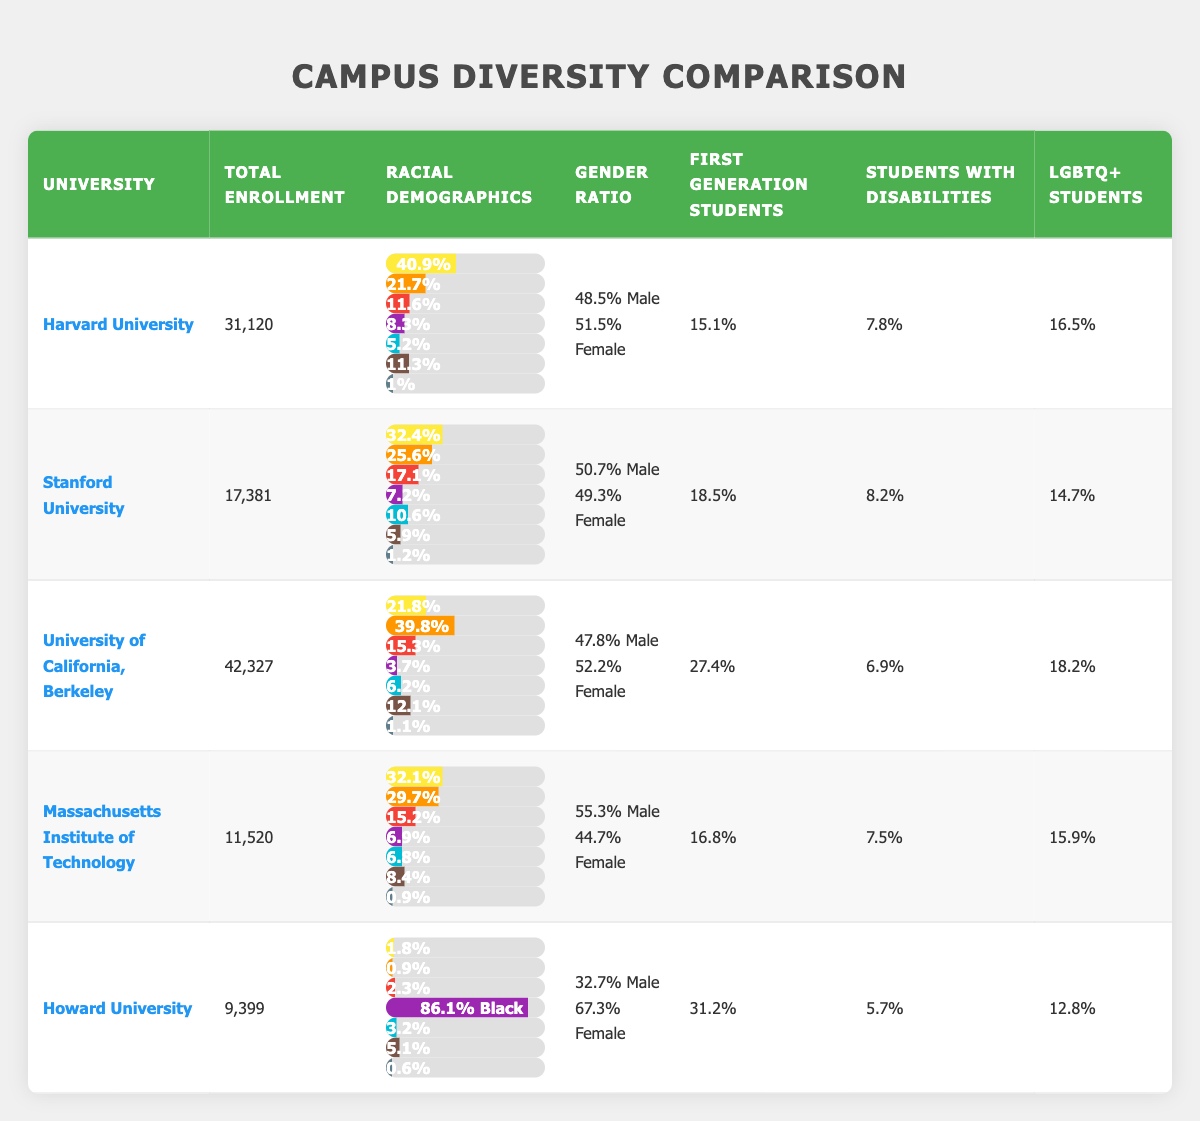What is the total enrollment at Harvard University? The table indicates that the total enrollment for Harvard University is listed as 31,120.
Answer: 31,120 Which university has the highest percentage of Asian students? By examining the racial demographics of the five universities, the University of California, Berkeley has the highest percentage of Asian students at 39.8%.
Answer: 39.8% What is the average percentage of first-generation students across all universities listed? The percentages for first-generation students are: Harvard (15.1), Stanford (18.5), UC Berkeley (27.4), MIT (16.8), and Howard (31.2). Adding these gives 108.0, and dividing by 5 (the number of universities) results in an average of 21.6%.
Answer: 21.6% Is Howard University the only university with a majority of Black students? The percentage of Black students at Howard University is 86.1%, which is significantly higher than that of other universities. The next highest percentage is at Stanford, with only 7.2%, thus confirming that Howard is the only university with a majority of Black students.
Answer: Yes Which university has a gender ratio closest to equal? To find the gender ratio closest to equal, we compare the values of male and female percentages across the universities. At Stanford University, the ratio is 50.7% male and 49.3% female, making it closest to an equal distribution.
Answer: Stanford University What is the combined percentage of students with disabilities at both Howard University and UC Berkeley? Howard University has 5.7% of students with disabilities and UC Berkeley has 6.9%. Adding these two percentages gives 5.7 + 6.9 = 12.6%.
Answer: 12.6% Are there any universities listed where female students make up over 60% of the total enrollment? Looking at the gender ratios in the table, Howard University has 67.3% female students, which is above 60%, while other universities have less than this percentage.
Answer: Yes What is the difference in enrollment between the largest and smallest universities in the table? The total enrollment of the largest university, UC Berkeley, is 42,327, while the smallest, Howard University, has 9,399. The difference is 42,327 - 9,399 = 32,928.
Answer: 32,928 